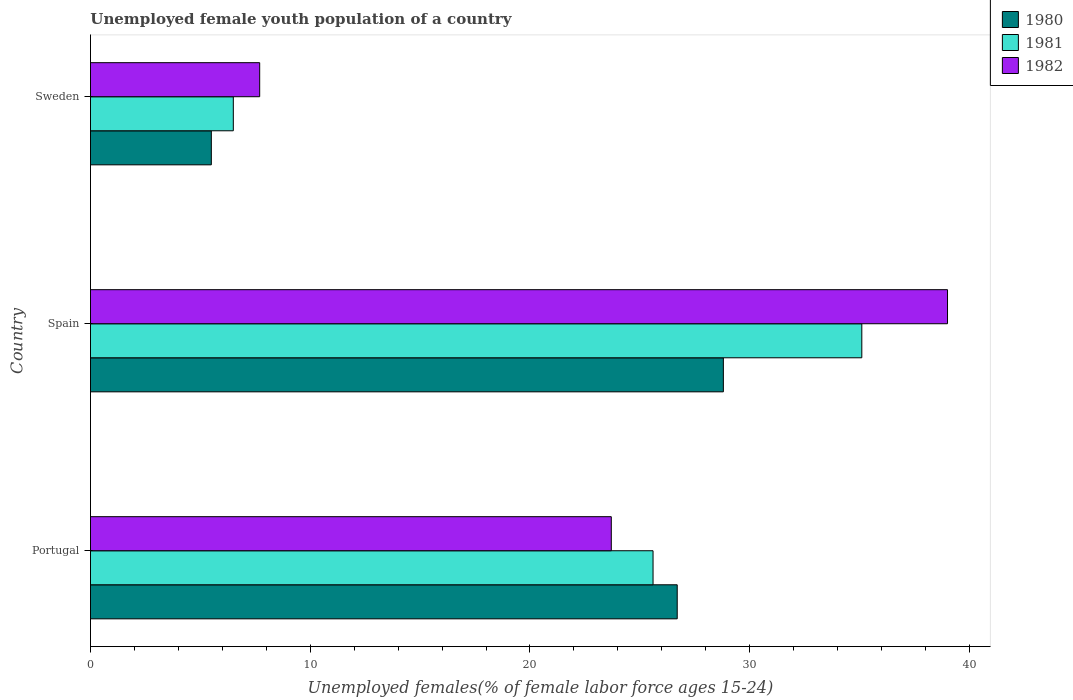How many different coloured bars are there?
Make the answer very short. 3. How many bars are there on the 1st tick from the top?
Provide a succinct answer. 3. What is the percentage of unemployed female youth population in 1981 in Sweden?
Offer a terse response. 6.5. Across all countries, what is the maximum percentage of unemployed female youth population in 1980?
Your answer should be compact. 28.8. Across all countries, what is the minimum percentage of unemployed female youth population in 1982?
Provide a succinct answer. 7.7. In which country was the percentage of unemployed female youth population in 1982 maximum?
Offer a terse response. Spain. What is the total percentage of unemployed female youth population in 1982 in the graph?
Your answer should be compact. 70.4. What is the difference between the percentage of unemployed female youth population in 1980 in Portugal and that in Sweden?
Ensure brevity in your answer.  21.2. What is the difference between the percentage of unemployed female youth population in 1980 in Spain and the percentage of unemployed female youth population in 1981 in Sweden?
Provide a succinct answer. 22.3. What is the average percentage of unemployed female youth population in 1980 per country?
Make the answer very short. 20.33. What is the difference between the percentage of unemployed female youth population in 1981 and percentage of unemployed female youth population in 1982 in Sweden?
Your answer should be very brief. -1.2. What is the ratio of the percentage of unemployed female youth population in 1982 in Portugal to that in Sweden?
Give a very brief answer. 3.08. Is the difference between the percentage of unemployed female youth population in 1981 in Portugal and Sweden greater than the difference between the percentage of unemployed female youth population in 1982 in Portugal and Sweden?
Provide a succinct answer. Yes. What is the difference between the highest and the second highest percentage of unemployed female youth population in 1982?
Give a very brief answer. 15.3. What is the difference between the highest and the lowest percentage of unemployed female youth population in 1982?
Give a very brief answer. 31.3. In how many countries, is the percentage of unemployed female youth population in 1980 greater than the average percentage of unemployed female youth population in 1980 taken over all countries?
Keep it short and to the point. 2. Is the sum of the percentage of unemployed female youth population in 1980 in Portugal and Sweden greater than the maximum percentage of unemployed female youth population in 1981 across all countries?
Provide a short and direct response. No. What does the 1st bar from the top in Portugal represents?
Ensure brevity in your answer.  1982. What does the 3rd bar from the bottom in Spain represents?
Your response must be concise. 1982. Is it the case that in every country, the sum of the percentage of unemployed female youth population in 1981 and percentage of unemployed female youth population in 1980 is greater than the percentage of unemployed female youth population in 1982?
Provide a short and direct response. Yes. How many bars are there?
Give a very brief answer. 9. How many countries are there in the graph?
Provide a short and direct response. 3. What is the difference between two consecutive major ticks on the X-axis?
Ensure brevity in your answer.  10. Are the values on the major ticks of X-axis written in scientific E-notation?
Provide a succinct answer. No. Does the graph contain grids?
Your answer should be compact. No. Where does the legend appear in the graph?
Offer a very short reply. Top right. How many legend labels are there?
Ensure brevity in your answer.  3. How are the legend labels stacked?
Keep it short and to the point. Vertical. What is the title of the graph?
Give a very brief answer. Unemployed female youth population of a country. Does "2004" appear as one of the legend labels in the graph?
Offer a very short reply. No. What is the label or title of the X-axis?
Provide a short and direct response. Unemployed females(% of female labor force ages 15-24). What is the Unemployed females(% of female labor force ages 15-24) in 1980 in Portugal?
Your answer should be very brief. 26.7. What is the Unemployed females(% of female labor force ages 15-24) in 1981 in Portugal?
Provide a short and direct response. 25.6. What is the Unemployed females(% of female labor force ages 15-24) in 1982 in Portugal?
Offer a terse response. 23.7. What is the Unemployed females(% of female labor force ages 15-24) in 1980 in Spain?
Offer a terse response. 28.8. What is the Unemployed females(% of female labor force ages 15-24) in 1981 in Spain?
Make the answer very short. 35.1. What is the Unemployed females(% of female labor force ages 15-24) in 1982 in Spain?
Make the answer very short. 39. What is the Unemployed females(% of female labor force ages 15-24) in 1980 in Sweden?
Give a very brief answer. 5.5. What is the Unemployed females(% of female labor force ages 15-24) in 1982 in Sweden?
Make the answer very short. 7.7. Across all countries, what is the maximum Unemployed females(% of female labor force ages 15-24) in 1980?
Your answer should be compact. 28.8. Across all countries, what is the maximum Unemployed females(% of female labor force ages 15-24) in 1981?
Provide a succinct answer. 35.1. Across all countries, what is the minimum Unemployed females(% of female labor force ages 15-24) in 1981?
Provide a short and direct response. 6.5. Across all countries, what is the minimum Unemployed females(% of female labor force ages 15-24) of 1982?
Offer a very short reply. 7.7. What is the total Unemployed females(% of female labor force ages 15-24) in 1980 in the graph?
Offer a very short reply. 61. What is the total Unemployed females(% of female labor force ages 15-24) in 1981 in the graph?
Give a very brief answer. 67.2. What is the total Unemployed females(% of female labor force ages 15-24) of 1982 in the graph?
Your response must be concise. 70.4. What is the difference between the Unemployed females(% of female labor force ages 15-24) of 1980 in Portugal and that in Spain?
Offer a very short reply. -2.1. What is the difference between the Unemployed females(% of female labor force ages 15-24) of 1981 in Portugal and that in Spain?
Ensure brevity in your answer.  -9.5. What is the difference between the Unemployed females(% of female labor force ages 15-24) in 1982 in Portugal and that in Spain?
Provide a short and direct response. -15.3. What is the difference between the Unemployed females(% of female labor force ages 15-24) of 1980 in Portugal and that in Sweden?
Provide a short and direct response. 21.2. What is the difference between the Unemployed females(% of female labor force ages 15-24) in 1981 in Portugal and that in Sweden?
Make the answer very short. 19.1. What is the difference between the Unemployed females(% of female labor force ages 15-24) in 1982 in Portugal and that in Sweden?
Provide a short and direct response. 16. What is the difference between the Unemployed females(% of female labor force ages 15-24) of 1980 in Spain and that in Sweden?
Offer a very short reply. 23.3. What is the difference between the Unemployed females(% of female labor force ages 15-24) in 1981 in Spain and that in Sweden?
Ensure brevity in your answer.  28.6. What is the difference between the Unemployed females(% of female labor force ages 15-24) of 1982 in Spain and that in Sweden?
Offer a terse response. 31.3. What is the difference between the Unemployed females(% of female labor force ages 15-24) in 1980 in Portugal and the Unemployed females(% of female labor force ages 15-24) in 1981 in Spain?
Your answer should be compact. -8.4. What is the difference between the Unemployed females(% of female labor force ages 15-24) in 1980 in Portugal and the Unemployed females(% of female labor force ages 15-24) in 1982 in Spain?
Offer a very short reply. -12.3. What is the difference between the Unemployed females(% of female labor force ages 15-24) of 1981 in Portugal and the Unemployed females(% of female labor force ages 15-24) of 1982 in Spain?
Your answer should be very brief. -13.4. What is the difference between the Unemployed females(% of female labor force ages 15-24) of 1980 in Portugal and the Unemployed females(% of female labor force ages 15-24) of 1981 in Sweden?
Keep it short and to the point. 20.2. What is the difference between the Unemployed females(% of female labor force ages 15-24) in 1980 in Spain and the Unemployed females(% of female labor force ages 15-24) in 1981 in Sweden?
Give a very brief answer. 22.3. What is the difference between the Unemployed females(% of female labor force ages 15-24) in 1980 in Spain and the Unemployed females(% of female labor force ages 15-24) in 1982 in Sweden?
Make the answer very short. 21.1. What is the difference between the Unemployed females(% of female labor force ages 15-24) of 1981 in Spain and the Unemployed females(% of female labor force ages 15-24) of 1982 in Sweden?
Ensure brevity in your answer.  27.4. What is the average Unemployed females(% of female labor force ages 15-24) of 1980 per country?
Keep it short and to the point. 20.33. What is the average Unemployed females(% of female labor force ages 15-24) of 1981 per country?
Ensure brevity in your answer.  22.4. What is the average Unemployed females(% of female labor force ages 15-24) of 1982 per country?
Keep it short and to the point. 23.47. What is the difference between the Unemployed females(% of female labor force ages 15-24) of 1980 and Unemployed females(% of female labor force ages 15-24) of 1981 in Portugal?
Offer a very short reply. 1.1. What is the difference between the Unemployed females(% of female labor force ages 15-24) in 1980 and Unemployed females(% of female labor force ages 15-24) in 1982 in Portugal?
Provide a short and direct response. 3. What is the difference between the Unemployed females(% of female labor force ages 15-24) in 1981 and Unemployed females(% of female labor force ages 15-24) in 1982 in Portugal?
Your answer should be very brief. 1.9. What is the difference between the Unemployed females(% of female labor force ages 15-24) in 1980 and Unemployed females(% of female labor force ages 15-24) in 1981 in Spain?
Give a very brief answer. -6.3. What is the difference between the Unemployed females(% of female labor force ages 15-24) in 1980 and Unemployed females(% of female labor force ages 15-24) in 1981 in Sweden?
Your response must be concise. -1. What is the difference between the Unemployed females(% of female labor force ages 15-24) of 1980 and Unemployed females(% of female labor force ages 15-24) of 1982 in Sweden?
Your answer should be very brief. -2.2. What is the difference between the Unemployed females(% of female labor force ages 15-24) of 1981 and Unemployed females(% of female labor force ages 15-24) of 1982 in Sweden?
Provide a succinct answer. -1.2. What is the ratio of the Unemployed females(% of female labor force ages 15-24) in 1980 in Portugal to that in Spain?
Your response must be concise. 0.93. What is the ratio of the Unemployed females(% of female labor force ages 15-24) in 1981 in Portugal to that in Spain?
Provide a short and direct response. 0.73. What is the ratio of the Unemployed females(% of female labor force ages 15-24) in 1982 in Portugal to that in Spain?
Your answer should be compact. 0.61. What is the ratio of the Unemployed females(% of female labor force ages 15-24) in 1980 in Portugal to that in Sweden?
Keep it short and to the point. 4.85. What is the ratio of the Unemployed females(% of female labor force ages 15-24) of 1981 in Portugal to that in Sweden?
Provide a succinct answer. 3.94. What is the ratio of the Unemployed females(% of female labor force ages 15-24) in 1982 in Portugal to that in Sweden?
Provide a short and direct response. 3.08. What is the ratio of the Unemployed females(% of female labor force ages 15-24) in 1980 in Spain to that in Sweden?
Provide a succinct answer. 5.24. What is the ratio of the Unemployed females(% of female labor force ages 15-24) of 1982 in Spain to that in Sweden?
Your answer should be very brief. 5.06. What is the difference between the highest and the second highest Unemployed females(% of female labor force ages 15-24) of 1982?
Provide a succinct answer. 15.3. What is the difference between the highest and the lowest Unemployed females(% of female labor force ages 15-24) of 1980?
Your answer should be very brief. 23.3. What is the difference between the highest and the lowest Unemployed females(% of female labor force ages 15-24) of 1981?
Offer a terse response. 28.6. What is the difference between the highest and the lowest Unemployed females(% of female labor force ages 15-24) in 1982?
Provide a short and direct response. 31.3. 